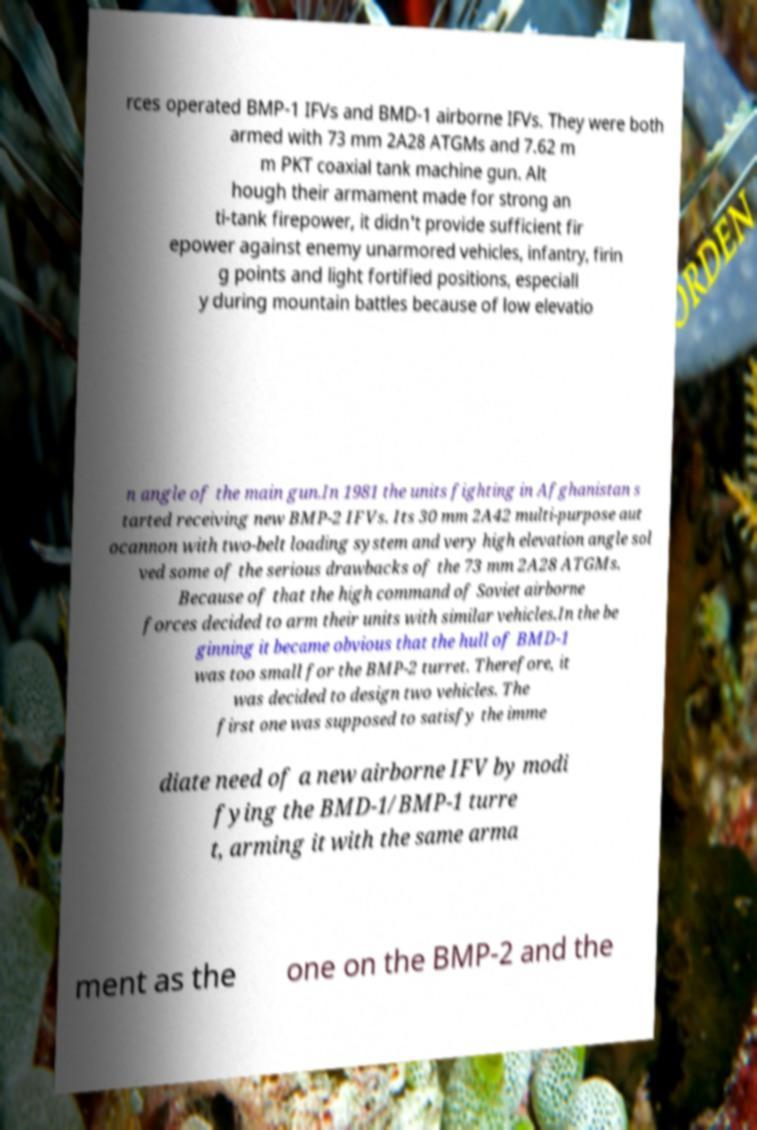I need the written content from this picture converted into text. Can you do that? rces operated BMP-1 IFVs and BMD-1 airborne IFVs. They were both armed with 73 mm 2A28 ATGMs and 7.62 m m PKT coaxial tank machine gun. Alt hough their armament made for strong an ti-tank firepower, it didn't provide sufficient fir epower against enemy unarmored vehicles, infantry, firin g points and light fortified positions, especiall y during mountain battles because of low elevatio n angle of the main gun.In 1981 the units fighting in Afghanistan s tarted receiving new BMP-2 IFVs. Its 30 mm 2A42 multi-purpose aut ocannon with two-belt loading system and very high elevation angle sol ved some of the serious drawbacks of the 73 mm 2A28 ATGMs. Because of that the high command of Soviet airborne forces decided to arm their units with similar vehicles.In the be ginning it became obvious that the hull of BMD-1 was too small for the BMP-2 turret. Therefore, it was decided to design two vehicles. The first one was supposed to satisfy the imme diate need of a new airborne IFV by modi fying the BMD-1/BMP-1 turre t, arming it with the same arma ment as the one on the BMP-2 and the 